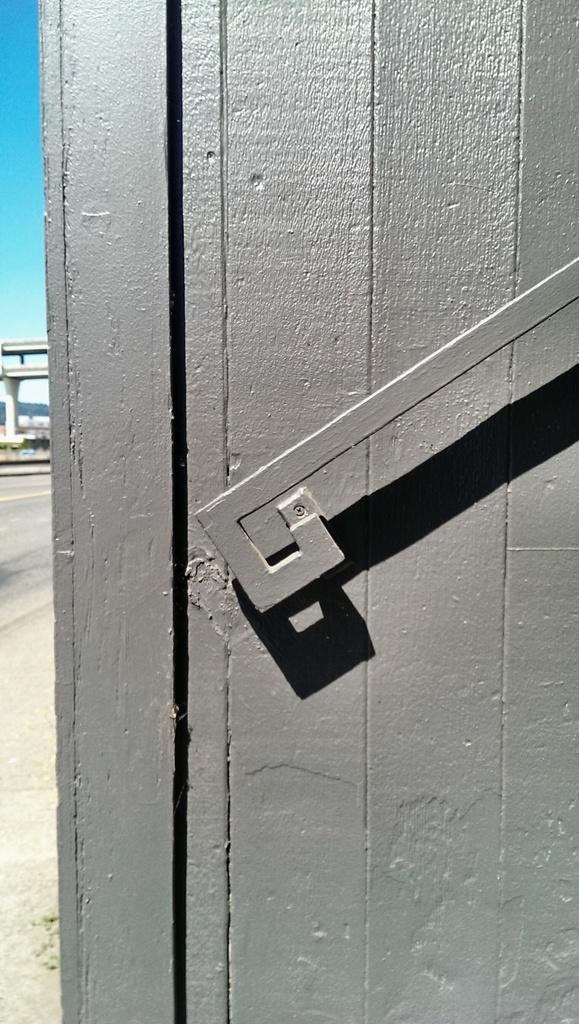What type of wall is visible in the front of the image? There is a wooden wall in the front of the image. What structure can be seen on the left side of the image? There is a bridge on the left side of the image. What part of the sky is visible in the image? The sky is visible at the left top of the image. What type of agreement is being discussed at the party in the image? There is no party present in the image, and therefore no agreement being discussed. What kind of pancake is being served at the wooden wall in the image? There is no pancake present in the image, and the wooden wall is not serving any food. 